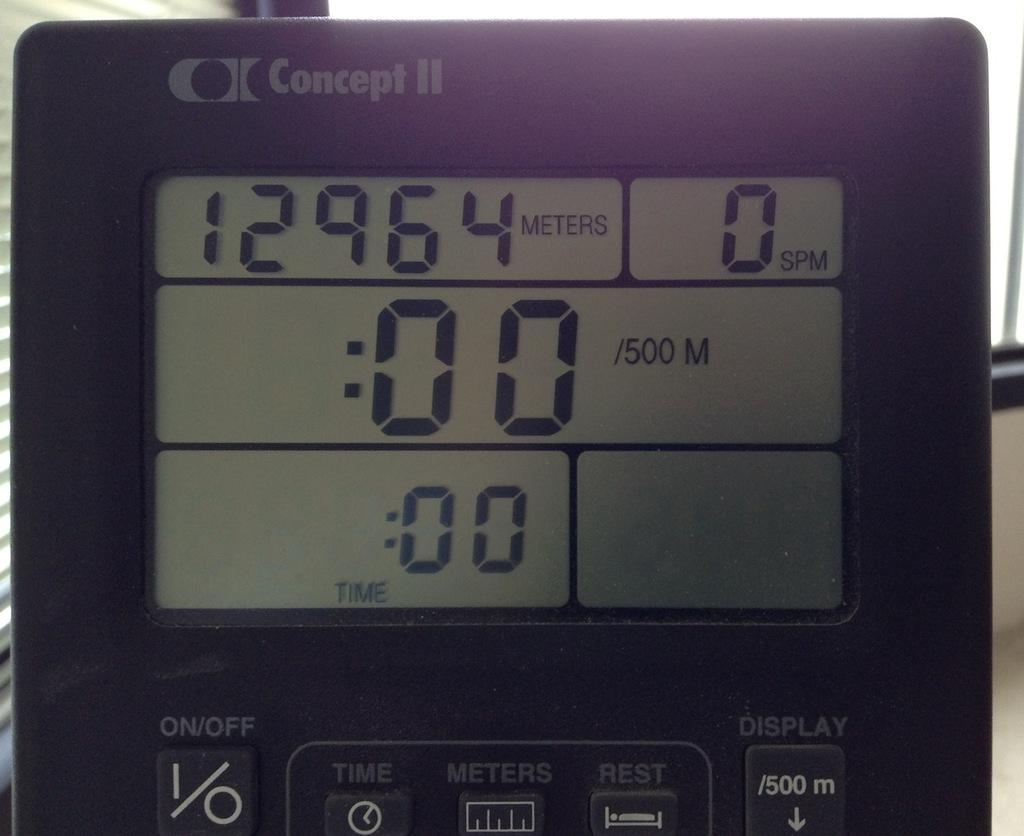Provide a one-sentence caption for the provided image. A small black step counter timer by Concept H. 